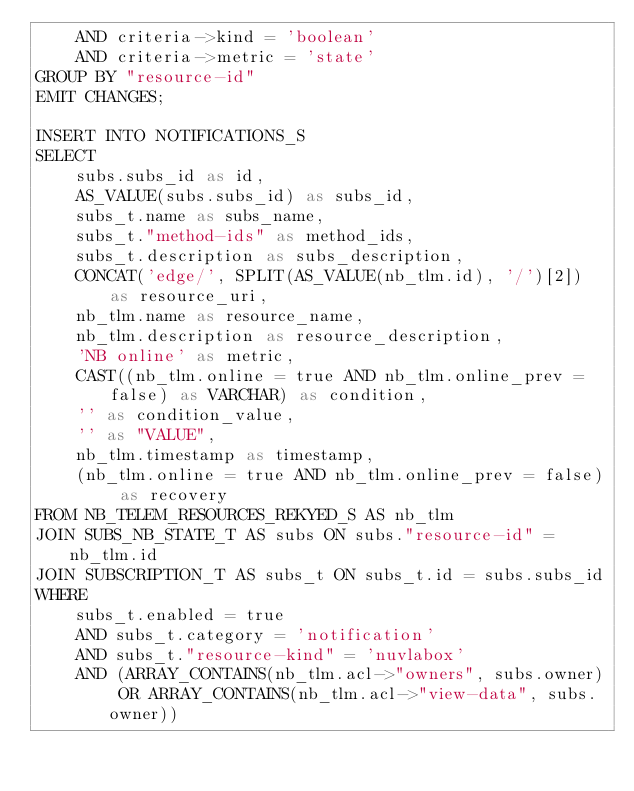Convert code to text. <code><loc_0><loc_0><loc_500><loc_500><_SQL_>    AND criteria->kind = 'boolean'
    AND criteria->metric = 'state'
GROUP BY "resource-id"
EMIT CHANGES;

INSERT INTO NOTIFICATIONS_S
SELECT
    subs.subs_id as id,
    AS_VALUE(subs.subs_id) as subs_id,
    subs_t.name as subs_name,
    subs_t."method-ids" as method_ids,
    subs_t.description as subs_description,
    CONCAT('edge/', SPLIT(AS_VALUE(nb_tlm.id), '/')[2]) as resource_uri,
    nb_tlm.name as resource_name,
    nb_tlm.description as resource_description,
    'NB online' as metric,
    CAST((nb_tlm.online = true AND nb_tlm.online_prev = false) as VARCHAR) as condition,
    '' as condition_value,
    '' as "VALUE",
    nb_tlm.timestamp as timestamp,
    (nb_tlm.online = true AND nb_tlm.online_prev = false) as recovery
FROM NB_TELEM_RESOURCES_REKYED_S AS nb_tlm
JOIN SUBS_NB_STATE_T AS subs ON subs."resource-id" = nb_tlm.id
JOIN SUBSCRIPTION_T AS subs_t ON subs_t.id = subs.subs_id
WHERE
    subs_t.enabled = true
    AND subs_t.category = 'notification'
    AND subs_t."resource-kind" = 'nuvlabox'
    AND (ARRAY_CONTAINS(nb_tlm.acl->"owners", subs.owner) OR ARRAY_CONTAINS(nb_tlm.acl->"view-data", subs.owner))</code> 